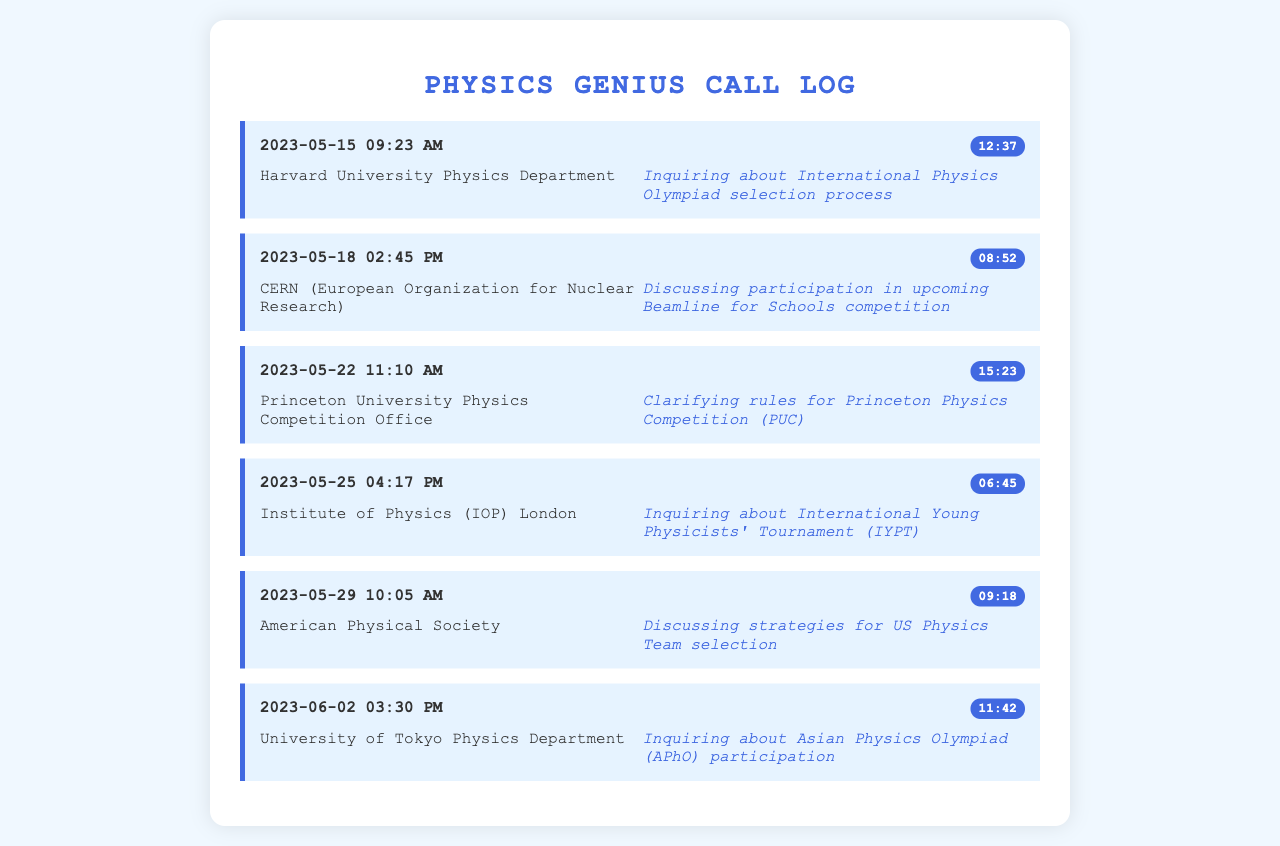what was the date of the first recorded call? The first recorded call in the document is on May 15, 2023.
Answer: May 15, 2023 who was the contact for the inquiry about the International Physics Olympiad? The contact for the inquiry was Harvard University Physics Department.
Answer: Harvard University Physics Department how long was the call with the American Physical Society? The duration of the call with the American Physical Society was 9 minutes and 18 seconds.
Answer: 09:18 which organization was contacted on May 22, 2023? The organization contacted on May 22, 2023, was Princeton University Physics Competition Office.
Answer: Princeton University Physics Competition Office what was the purpose of the call with the University of Tokyo Physics Department? The purpose of the call was to inquire about Asian Physics Olympiad participation.
Answer: Inquiring about Asian Physics Olympiad participation how many calls are recorded in the document? There are a total of six calls recorded in the document.
Answer: six what was discussed during the call with CERN? The discussion during the call with CERN was about participation in the upcoming Beamline for Schools competition.
Answer: Discussing participation in upcoming Beamline for Schools competition which call lasted the longest? The call that lasted the longest was with Princeton University Physics Competition Office.
Answer: Princeton University Physics Competition Office what time of day was the call with the Institute of Physics London made? The call with the Institute of Physics London was made in the afternoon.
Answer: afternoon 